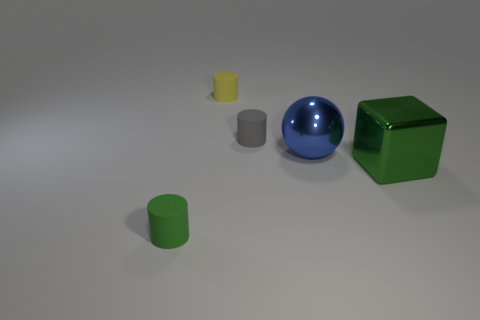There is a big sphere that is in front of the yellow matte object; what is it made of?
Your answer should be very brief. Metal. There is a metallic thing behind the big green block; is its size the same as the green thing to the left of the gray cylinder?
Make the answer very short. No. What is the shape of the large blue metal thing?
Offer a terse response. Sphere. How many spheres are big green metal objects or tiny yellow matte things?
Make the answer very short. 0. Are there an equal number of tiny yellow things to the right of the blue thing and tiny gray rubber cylinders behind the green metal object?
Your answer should be compact. No. There is a green object that is behind the matte thing that is in front of the big blue thing; how many small cylinders are behind it?
Ensure brevity in your answer.  2. What shape is the matte thing that is the same color as the big cube?
Provide a succinct answer. Cylinder. There is a big cube; does it have the same color as the cylinder in front of the green block?
Provide a short and direct response. Yes. Are there more small green rubber objects that are in front of the blue thing than big red metal cylinders?
Ensure brevity in your answer.  Yes. What number of things are rubber cylinders in front of the small yellow cylinder or rubber objects that are in front of the green metal thing?
Make the answer very short. 2. 